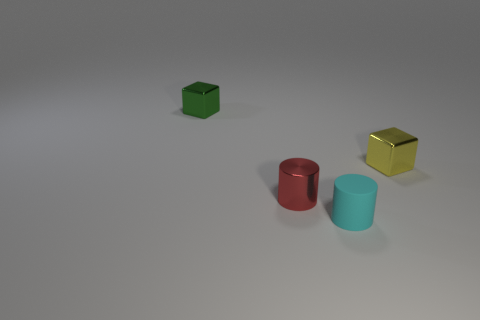Add 1 small yellow cubes. How many objects exist? 5 Subtract 1 green cubes. How many objects are left? 3 Subtract all cyan cubes. Subtract all green balls. How many cubes are left? 2 Subtract all tiny green objects. Subtract all tiny rubber cylinders. How many objects are left? 2 Add 1 tiny cyan objects. How many tiny cyan objects are left? 2 Add 1 small metallic blocks. How many small metallic blocks exist? 3 